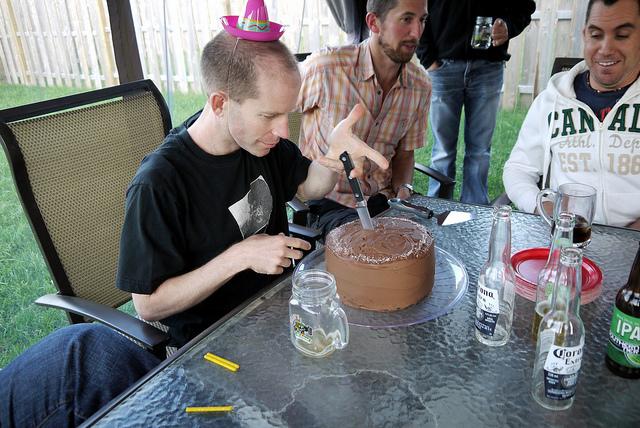What brand of beer do you see?
Concise answer only. Corona. What is on top of his head?
Keep it brief. Hat. Are both guys drinking beer?
Write a very short answer. Yes. What are the people about to eat?
Keep it brief. Cake. 